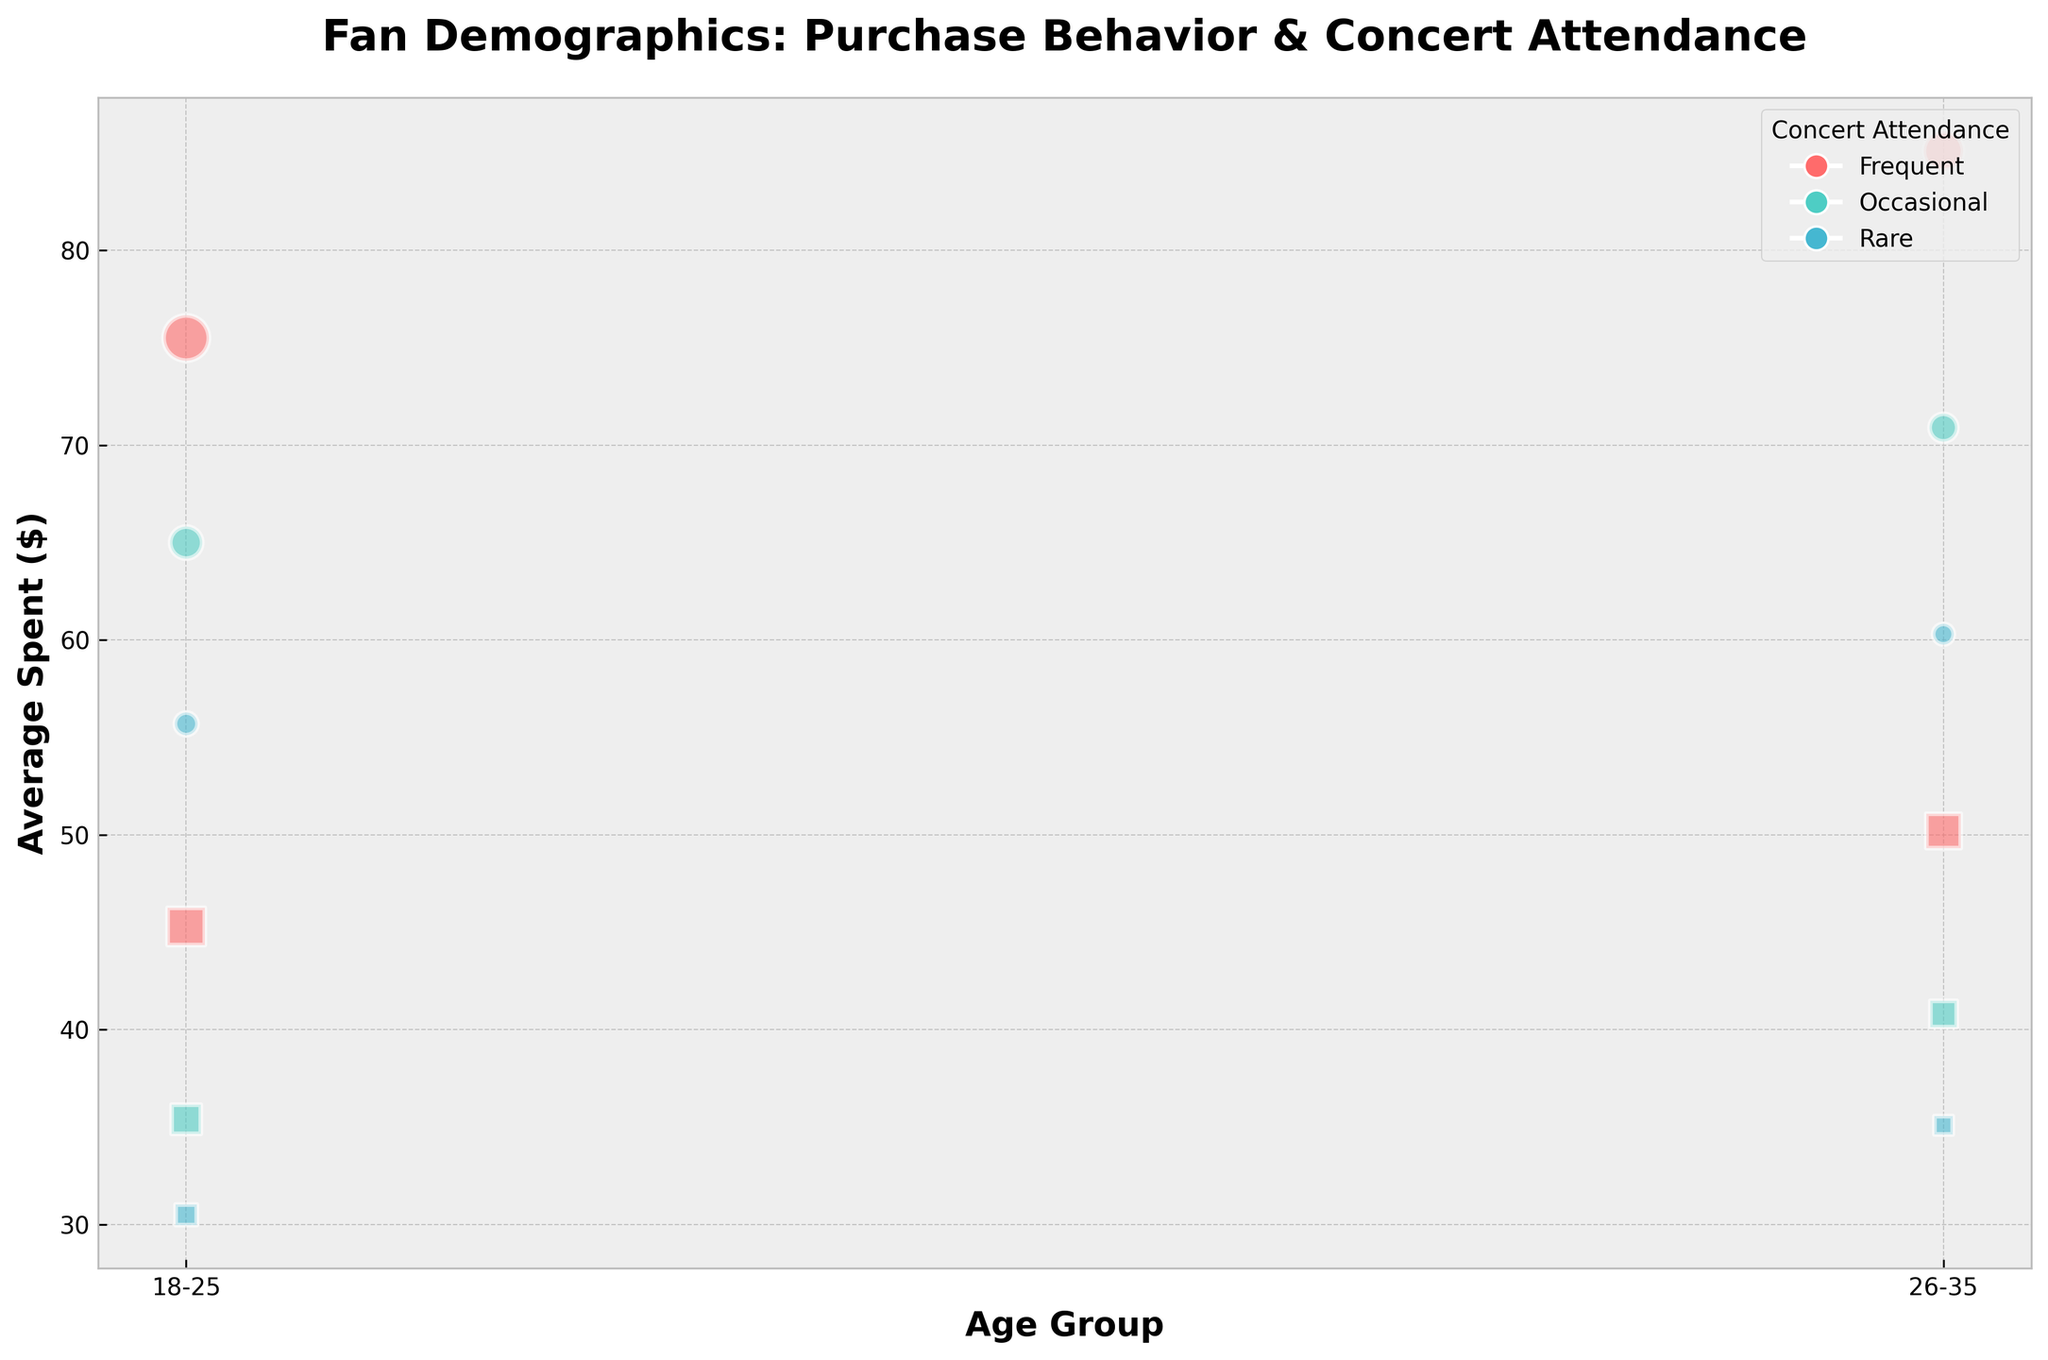What are the axes titles of the figure? The x-axis is labeled "Age Group" and the y-axis is labeled "Average Spent ($)".
Answer: "Age Group" (x-axis) and "Average Spent ($)" (y-axis) How many different concert attendance frequencies are represented in the figure? There are three different concert attendance frequencies represented by different colors: Frequent, Occasional, and Rare.
Answer: Three Which age group has the highest average spending for frequent concert attendees who purchase merch bundles? To find the highest average spent, look at the data points for the age groups 18-25 and 26-35 within the Frequent, Merch_Bundle category. The point for age group 26-35 is higher on the y-axis than 18-25.
Answer: 26-35 Which concert attendance frequency has the largest bubble for the 18-25 age group? Identify the largest bubble in the 18-25 age group by comparing bubble sizes. The largest bubble corresponds to Frequent concert attendance.
Answer: Frequent What is the average amount spent by occasional attendees who purchase individual items in the 18-25 age group? Find the bubble corresponding to Occasional attendees purchasing Individual Items in the 18-25 age group, and read its position on the y-axis.
Answer: $35.40 Which group has a higher average spending: occasional attendees buying merch bundles in the 26-35 age group or frequent attendees buying individual items in the 26-35 age group? Compare the y-axis positions of the bubbles for Occasional attendees (Merch_Bundle) and Frequent attendees (Individual_Item) in the 26-35 age group. The Occasional Merch_Bundle bubble is higher.
Answer: Occasional (Merch_Bundle) Are there more fans in the frequent or rare concert attendance category within the 18-25 age group who buy individual items? Compare the sizes of the bubbles for Frequent and Rare attendees in the 18-25 age group for Individual_Item purchase behavior. The larger bubble represents Frequent attendees.
Answer: Frequent For which age group and purchase behavior do rare concert attendees spend the least on average? Examine the bubbles for Rare attendees and compare their y-axis positions to find the lowest average spent. It is in the 18-25 age group, Individual_Item.
Answer: 18-25, Individual_Item Which has a larger number of fans: occasional merch bundle buyers aged 18-25 or rare individual item buyers aged 26-35? Compare the sizes of the corresponding bubbles for Occasional attendees (Merch_Bundle, 18-25) and Rare attendees (Individual_Item, 26-35). The larger bubble is for Occasional attendees.
Answer: Occasional (Merch_Bundle 18-25) Is the average spending of frequent attendees who purchase individual items in the 18-25 age group greater than that of rare attendees who purchase merch bundles in the same age group? Compare the y-axis positions of the bubbles for Frequent attendees (Individual_Item, 18-25) and Rare attendees (Merch_Bundle, 18-25). The Frequent attendees (Individual_Item) have a higher average spending.
Answer: Yes 